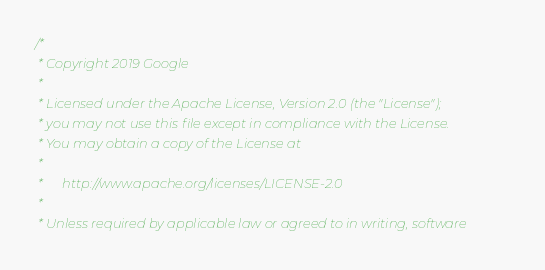Convert code to text. <code><loc_0><loc_0><loc_500><loc_500><_ObjectiveC_>/*
 * Copyright 2019 Google
 *
 * Licensed under the Apache License, Version 2.0 (the "License");
 * you may not use this file except in compliance with the License.
 * You may obtain a copy of the License at
 *
 *      http://www.apache.org/licenses/LICENSE-2.0
 *
 * Unless required by applicable law or agreed to in writing, software</code> 